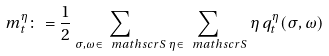Convert formula to latex. <formula><loc_0><loc_0><loc_500><loc_500>m ^ { \eta } _ { t } \colon = \frac { 1 } { 2 } \sum _ { \sigma , \omega \in \ m a t h s c r { S } } \sum _ { \eta \in \ m a t h s c r { S } } \eta \, q _ { t } ^ { \eta } ( \sigma , \omega )</formula> 